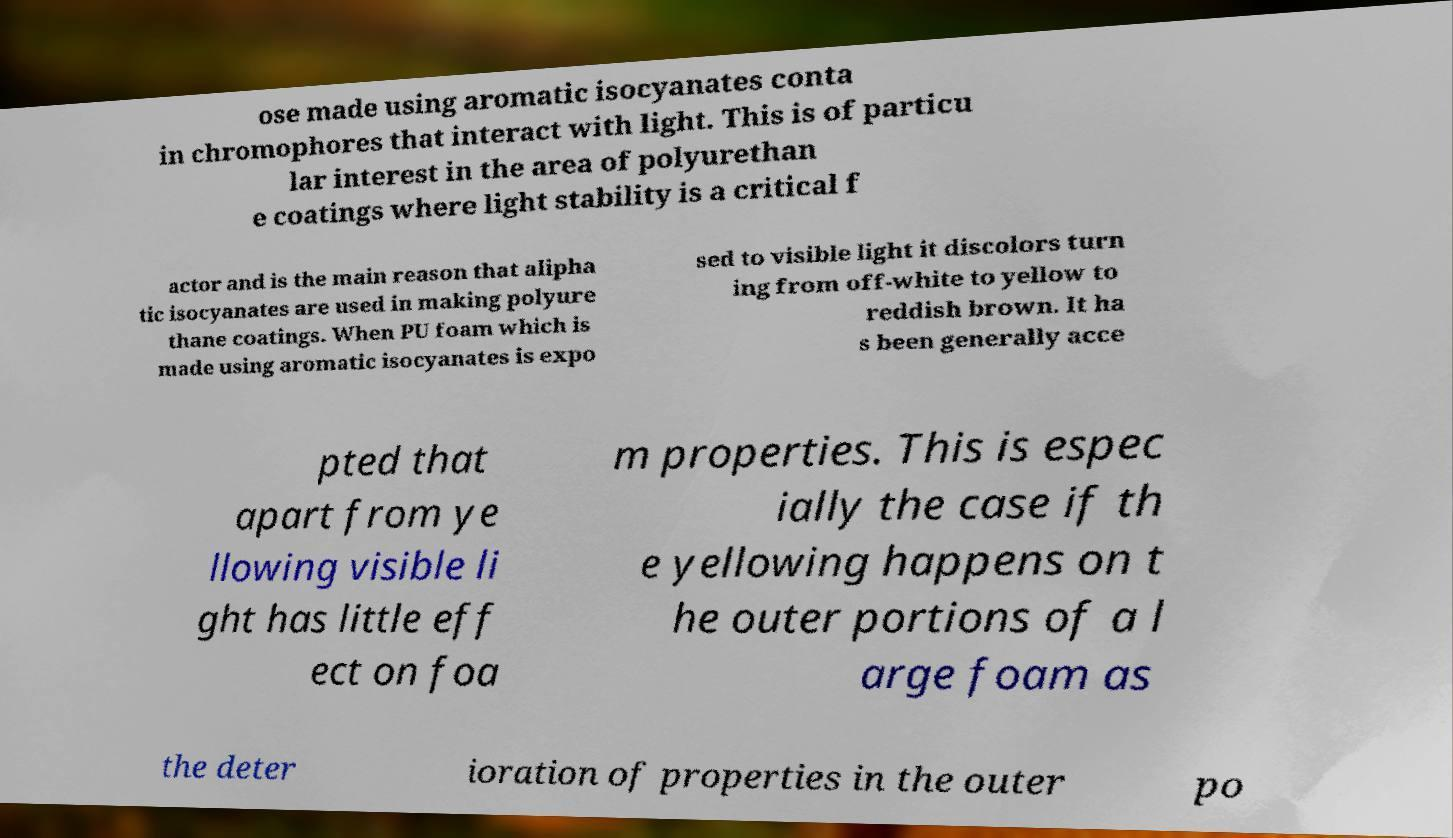For documentation purposes, I need the text within this image transcribed. Could you provide that? ose made using aromatic isocyanates conta in chromophores that interact with light. This is of particu lar interest in the area of polyurethan e coatings where light stability is a critical f actor and is the main reason that alipha tic isocyanates are used in making polyure thane coatings. When PU foam which is made using aromatic isocyanates is expo sed to visible light it discolors turn ing from off-white to yellow to reddish brown. It ha s been generally acce pted that apart from ye llowing visible li ght has little eff ect on foa m properties. This is espec ially the case if th e yellowing happens on t he outer portions of a l arge foam as the deter ioration of properties in the outer po 